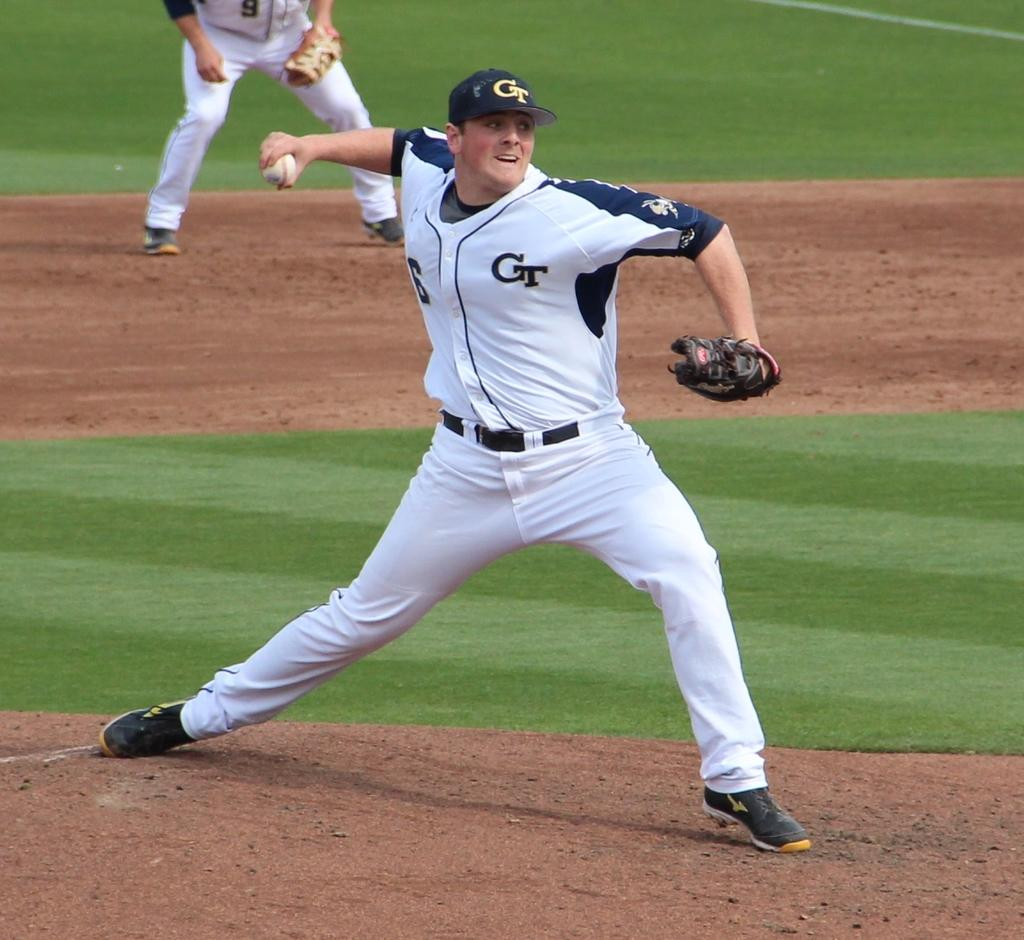<image>
Give a short and clear explanation of the subsequent image. A baseball pitcher about to throw the ball with the letters GT on his jersey. 